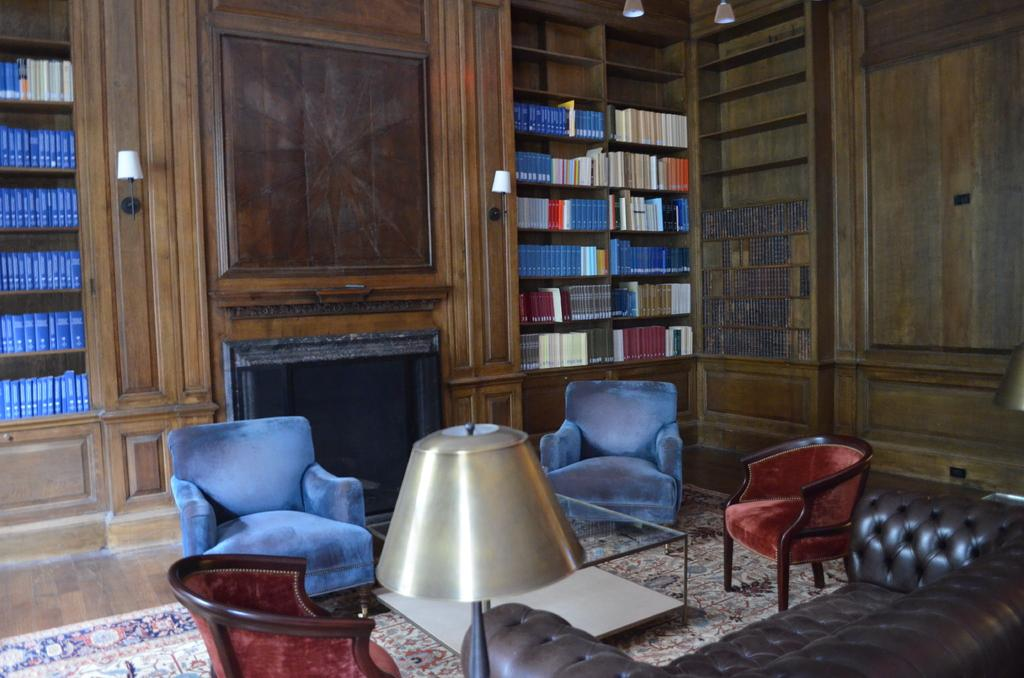What type of room is depicted in the image? There is a living room in the image. What type of furniture can be seen in the living room? There are sofa chairs and a sofa in the living room. How many chairs are present in the living room? There are two chairs in the living room. What type of lighting is present in the living room? There is a lamp in the living room. What type of decoration or storage can be seen in the living room? There are shelves with a large number of books in the living room. What type of sign can be seen on the wall in the living room? There is no sign visible on the wall in the living room in the image. What type of watch is placed on the table next to the sofa? There is no watch present on the table next to the sofa in the image. 